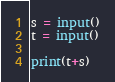Convert code to text. <code><loc_0><loc_0><loc_500><loc_500><_Python_>s = input()
t = input()

print(t+s)</code> 